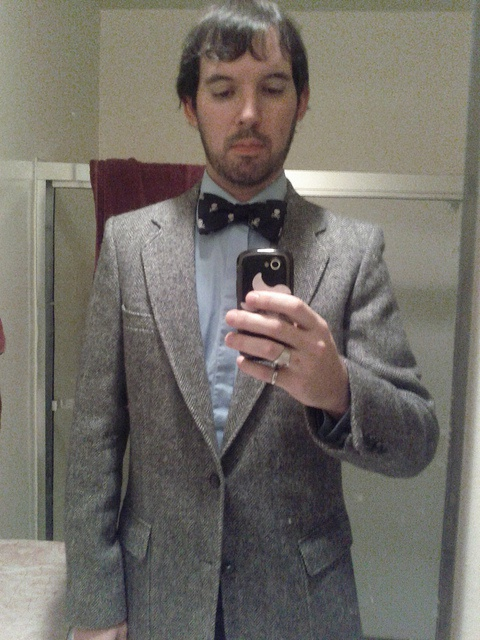Describe the objects in this image and their specific colors. I can see people in darkgray, gray, and black tones, tie in darkgray, black, and gray tones, and cell phone in darkgray, black, and gray tones in this image. 